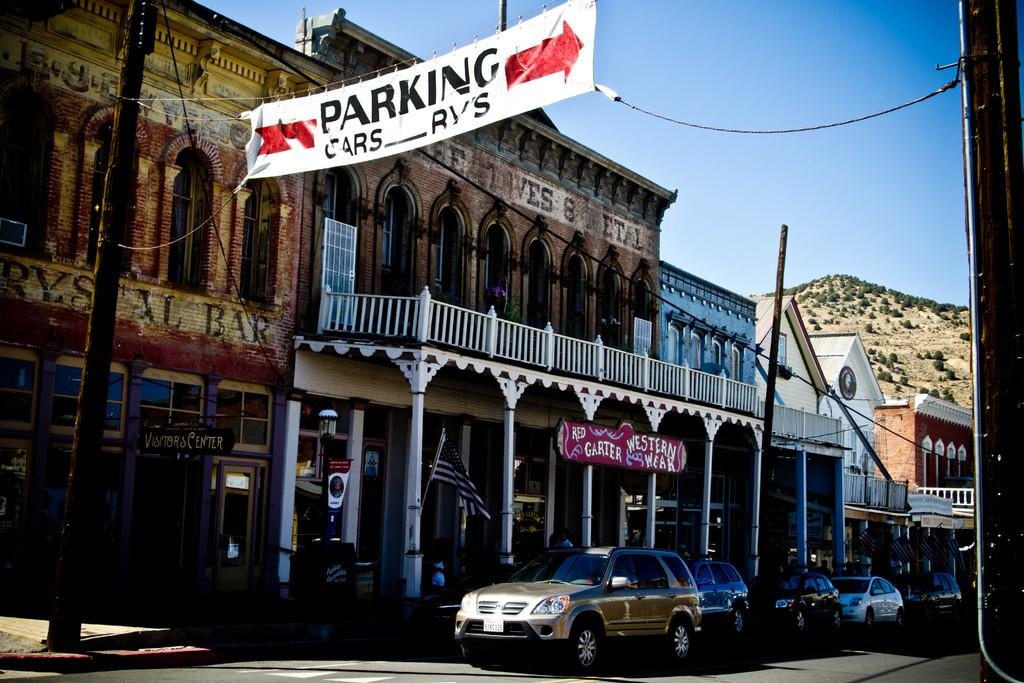<image>
Provide a brief description of the given image. a place that has the word parking above the hotel 